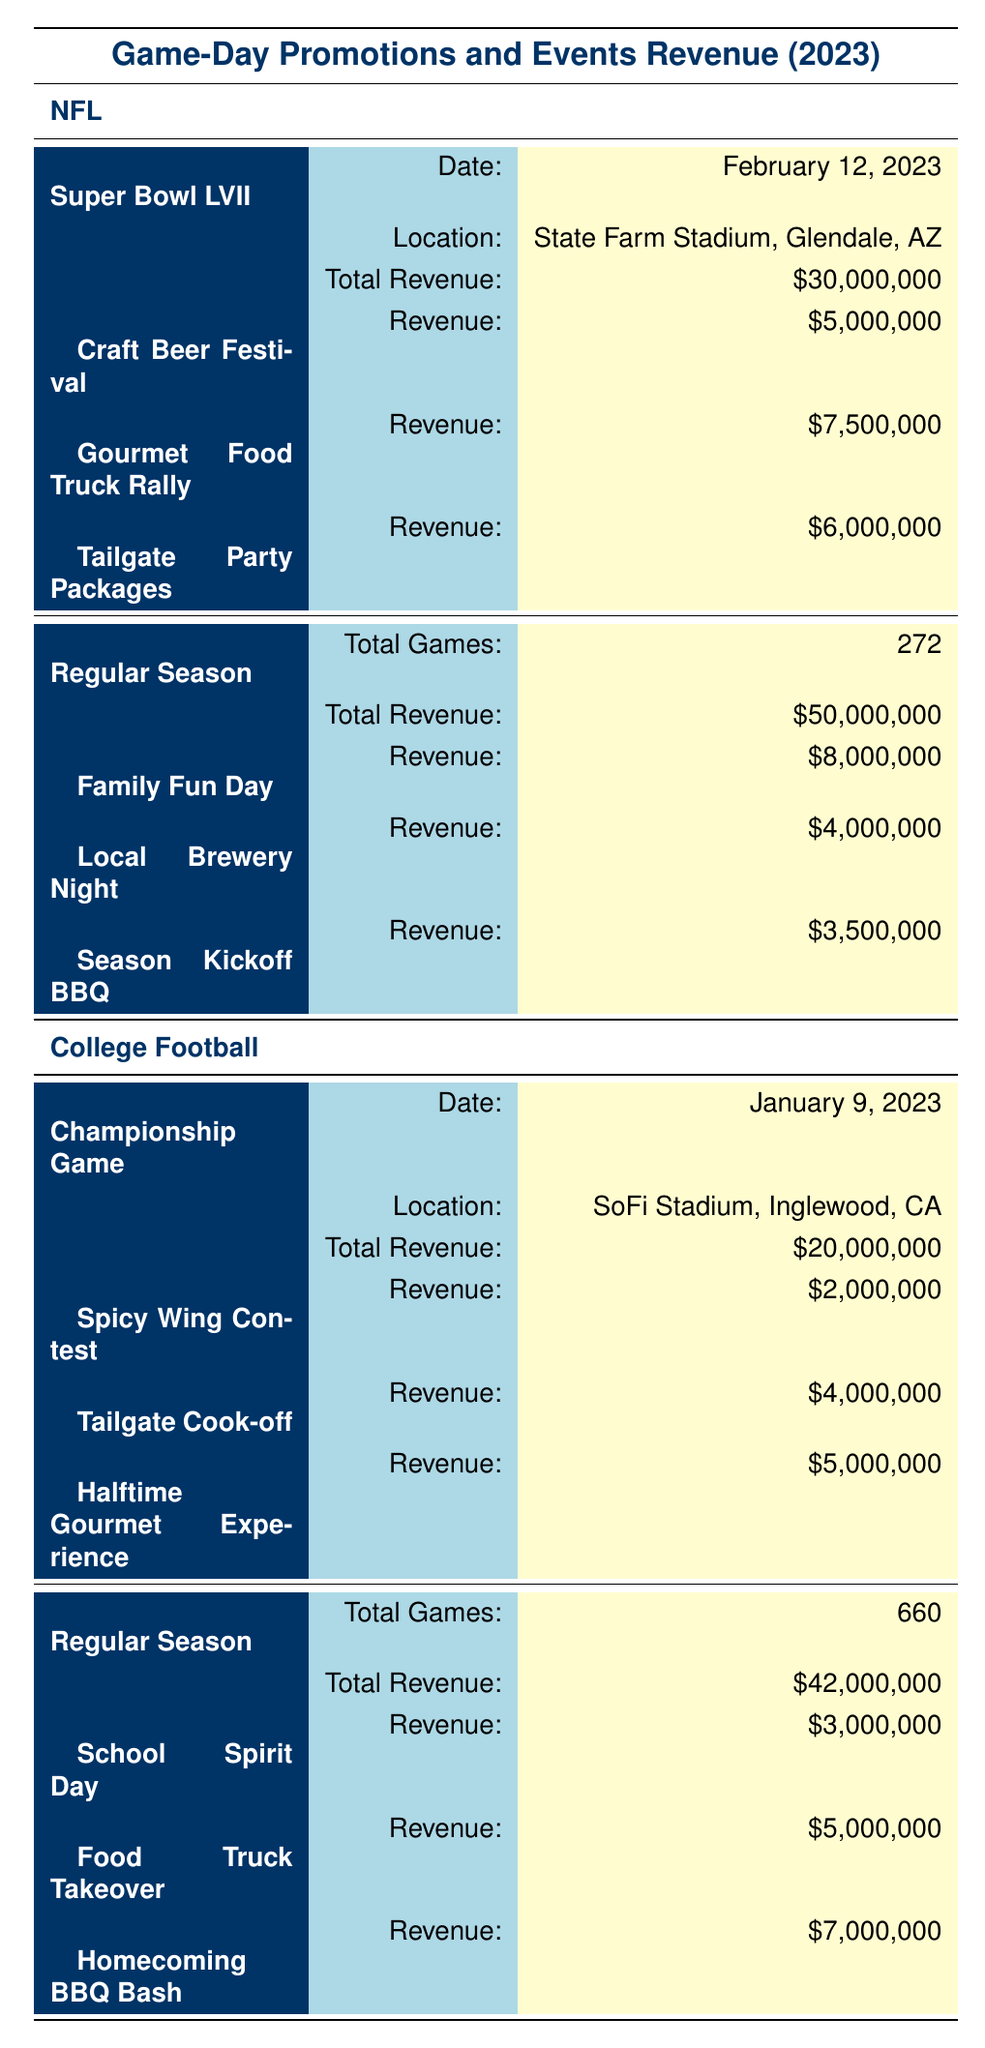What was the total revenue generated by the NFL Super Bowl LVII? The total revenue generated from the NFL Super Bowl LVII is listed directly in the table under the corresponding event details. It states a total revenue of $30,000,000.
Answer: 30,000,000 How much revenue did the "Gourmet Food Truck Rally" generate during the Super Bowl LVII? The revenue generated by the "Gourmet Food Truck Rally" is clearly stated in the promotions section of the Super Bowl LVII entry. It shows that this promotion earned $7,500,000.
Answer: 7,500,000 What is the total revenue generated from promotions during the College Football Regular Season? The table specifies individual promotion revenues within the College Football Regular Season, which are $3,000,000 for "School Spirit Day," $5,000,000 for "Food Truck Takeover," and $7,000,000 for "Homecoming BBQ Bash." Adding these values gives $3,000,000 + $5,000,000 + $7,000,000 = $15,000,000.
Answer: 15,000,000 Was the total revenue generated from the NFL Regular Season greater than that of the College Football Regular Season? The total revenue for the NFL Regular Season is $50,000,000 as stated in the table. The College Football Regular Season's total revenue is $42,000,000. Comparing the two figures, we see that $50,000,000 is greater than $42,000,000, making the statement true.
Answer: Yes How does the revenue from the "Tailgate Cook-off" compare to that of "Local Brewery Night"? The revenue from "Tailgate Cook-off" during the College Football Championship Game is $4,000,000, while "Local Brewery Night" during the NFL Regular Season earned $4,000,000 as well. Since both revenues are equal, their comparison shows they generate the same amount.
Answer: They are equal 